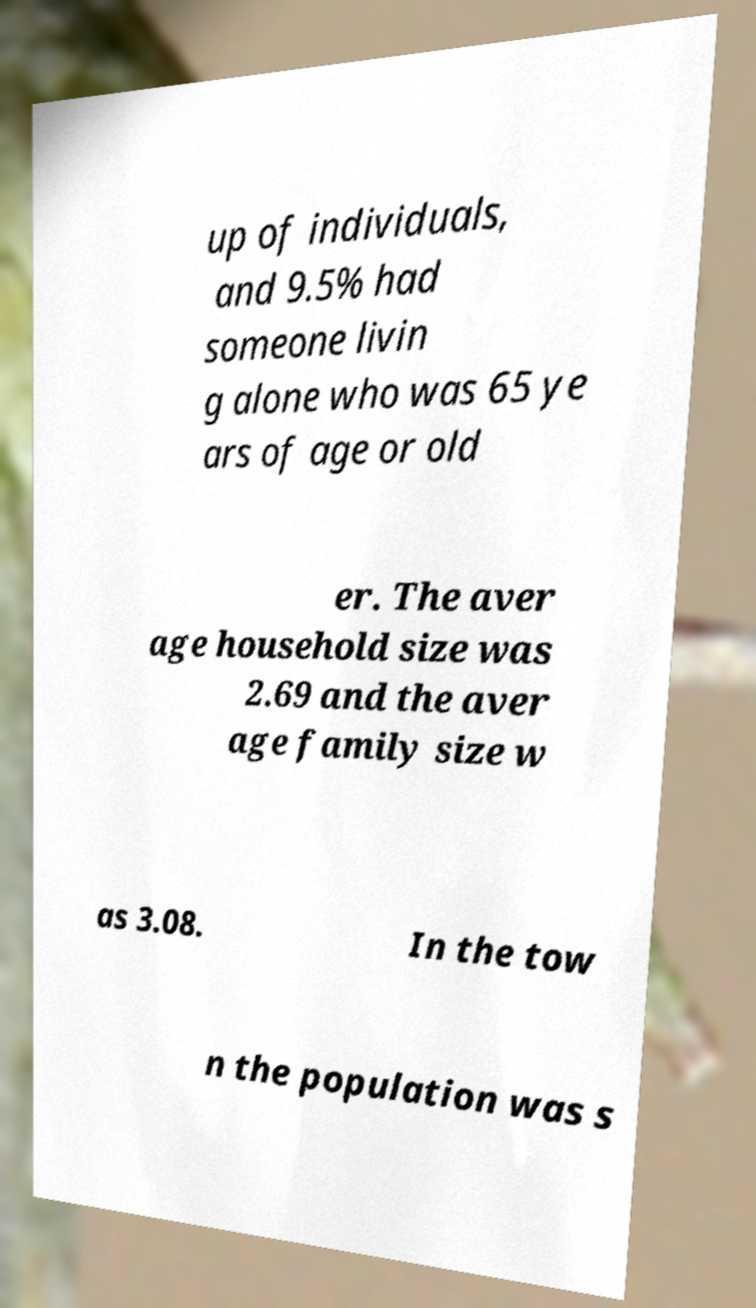Please identify and transcribe the text found in this image. up of individuals, and 9.5% had someone livin g alone who was 65 ye ars of age or old er. The aver age household size was 2.69 and the aver age family size w as 3.08. In the tow n the population was s 